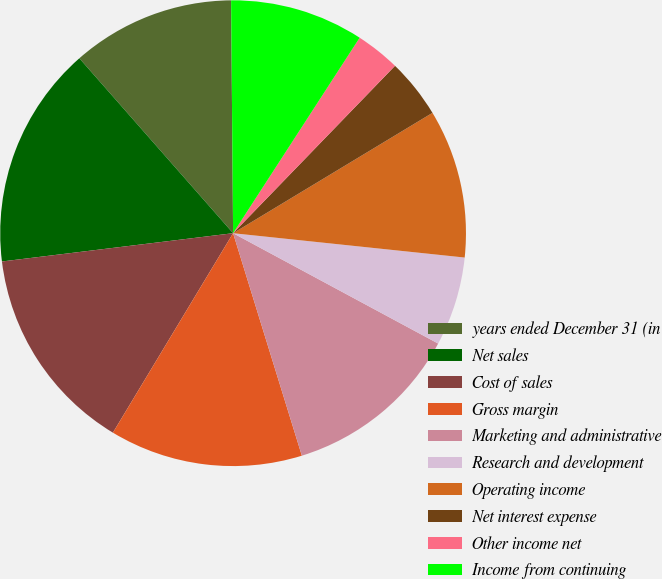<chart> <loc_0><loc_0><loc_500><loc_500><pie_chart><fcel>years ended December 31 (in<fcel>Net sales<fcel>Cost of sales<fcel>Gross margin<fcel>Marketing and administrative<fcel>Research and development<fcel>Operating income<fcel>Net interest expense<fcel>Other income net<fcel>Income from continuing<nl><fcel>11.34%<fcel>15.46%<fcel>14.43%<fcel>13.4%<fcel>12.37%<fcel>6.19%<fcel>10.31%<fcel>4.12%<fcel>3.09%<fcel>9.28%<nl></chart> 